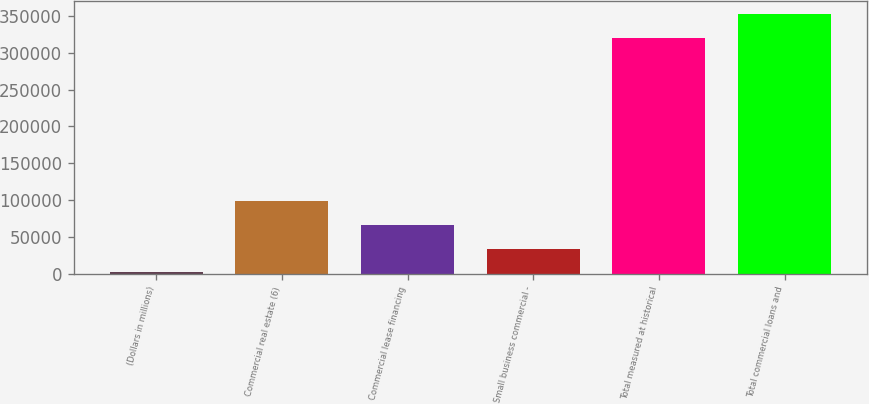<chart> <loc_0><loc_0><loc_500><loc_500><bar_chart><fcel>(Dollars in millions)<fcel>Commercial real estate (6)<fcel>Commercial lease financing<fcel>Small business commercial -<fcel>Total measured at historical<fcel>Total commercial loans and<nl><fcel>2007<fcel>98947.8<fcel>66634.2<fcel>34320.6<fcel>320553<fcel>352867<nl></chart> 